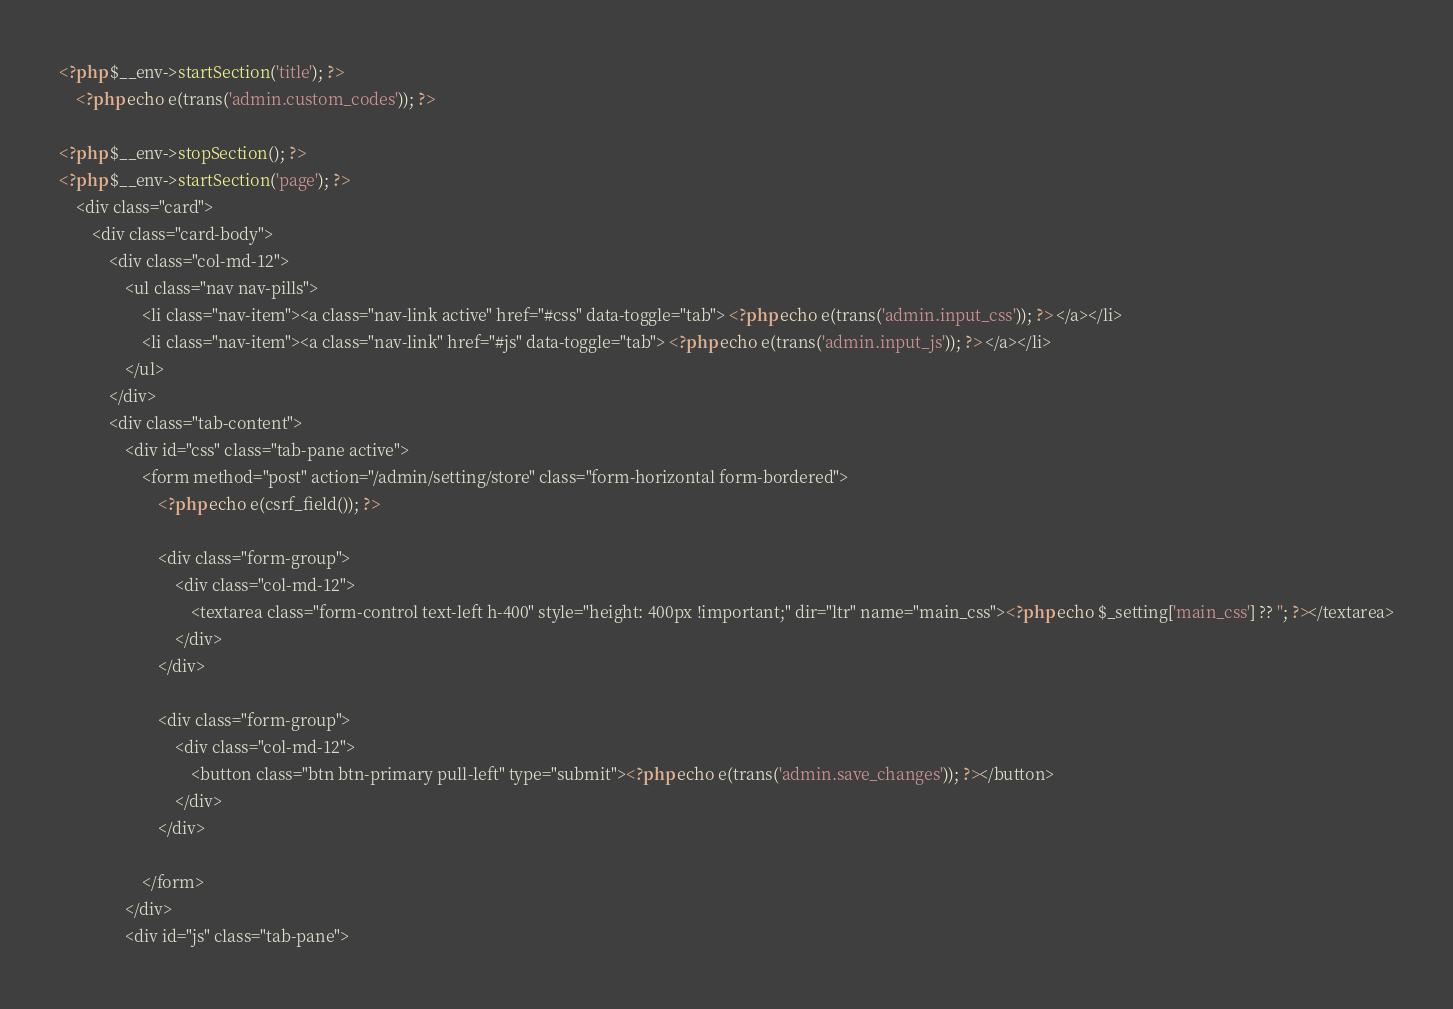<code> <loc_0><loc_0><loc_500><loc_500><_PHP_><?php $__env->startSection('title'); ?>
    <?php echo e(trans('admin.custom_codes')); ?>

<?php $__env->stopSection(); ?>
<?php $__env->startSection('page'); ?>
    <div class="card">
        <div class="card-body">
            <div class="col-md-12">
                <ul class="nav nav-pills">
                    <li class="nav-item"><a class="nav-link active" href="#css" data-toggle="tab"> <?php echo e(trans('admin.input_css')); ?> </a></li>
                    <li class="nav-item"><a class="nav-link" href="#js" data-toggle="tab"> <?php echo e(trans('admin.input_js')); ?> </a></li>
                </ul>
            </div>
            <div class="tab-content">
                <div id="css" class="tab-pane active">
                    <form method="post" action="/admin/setting/store" class="form-horizontal form-bordered">
                        <?php echo e(csrf_field()); ?>

                        <div class="form-group">
                            <div class="col-md-12">
                                <textarea class="form-control text-left h-400" style="height: 400px !important;" dir="ltr" name="main_css"><?php echo $_setting['main_css'] ?? ''; ?></textarea>
                            </div>
                        </div>

                        <div class="form-group">
                            <div class="col-md-12">
                                <button class="btn btn-primary pull-left" type="submit"><?php echo e(trans('admin.save_changes')); ?></button>
                            </div>
                        </div>

                    </form>
                </div>
                <div id="js" class="tab-pane"></code> 